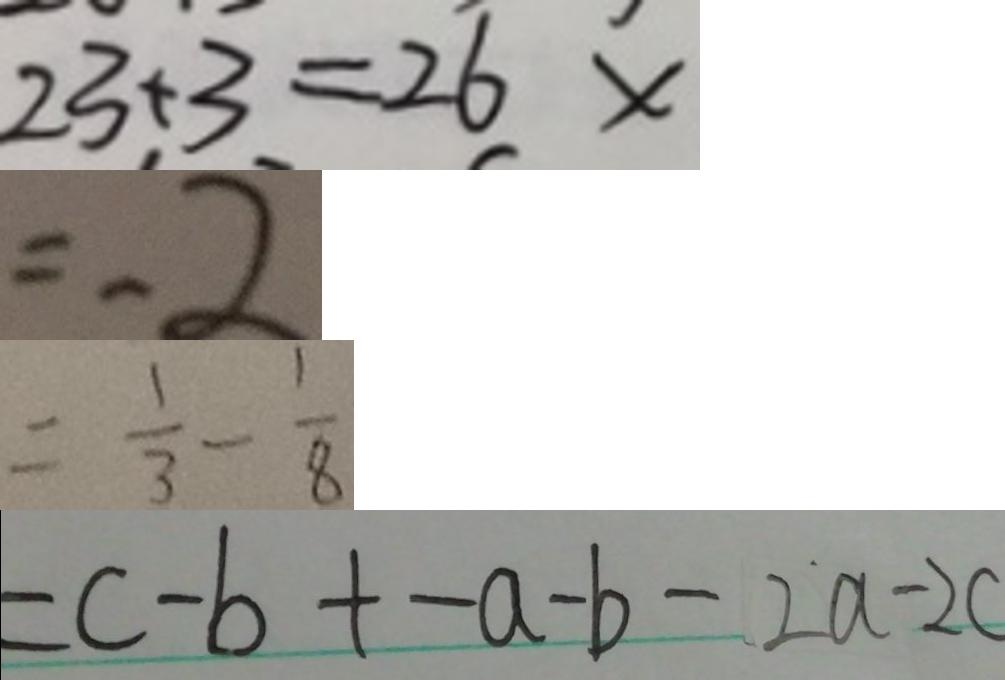Convert formula to latex. <formula><loc_0><loc_0><loc_500><loc_500>2 3 + 3 = 2 6 \times 
 = - 2 
 = \frac { 1 } { 3 } - \frac { 1 } { 8 } 
 = c - b + - a - b - 2 a - 2 c</formula> 